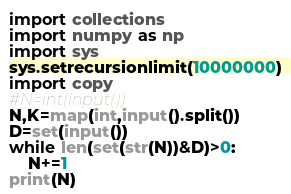<code> <loc_0><loc_0><loc_500><loc_500><_Python_>import collections
import numpy as np
import sys
sys.setrecursionlimit(10000000)
import copy
#N=int(input())
N,K=map(int,input().split())
D=set(input())
while len(set(str(N))&D)>0:
    N+=1
print(N)
</code> 